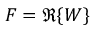Convert formula to latex. <formula><loc_0><loc_0><loc_500><loc_500>F = \Re \{ W \}</formula> 